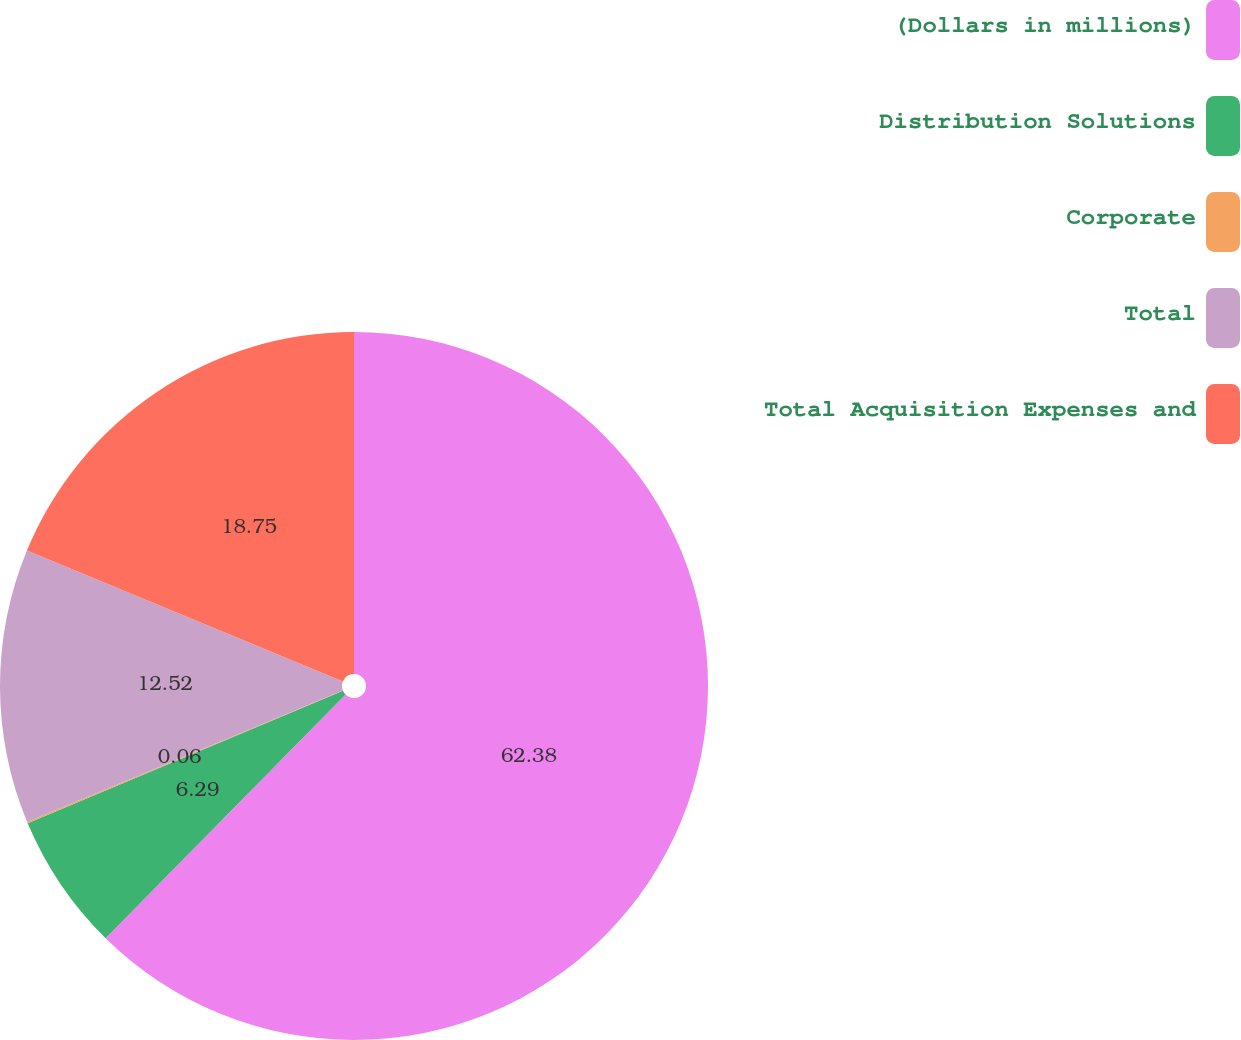Convert chart to OTSL. <chart><loc_0><loc_0><loc_500><loc_500><pie_chart><fcel>(Dollars in millions)<fcel>Distribution Solutions<fcel>Corporate<fcel>Total<fcel>Total Acquisition Expenses and<nl><fcel>62.37%<fcel>6.29%<fcel>0.06%<fcel>12.52%<fcel>18.75%<nl></chart> 